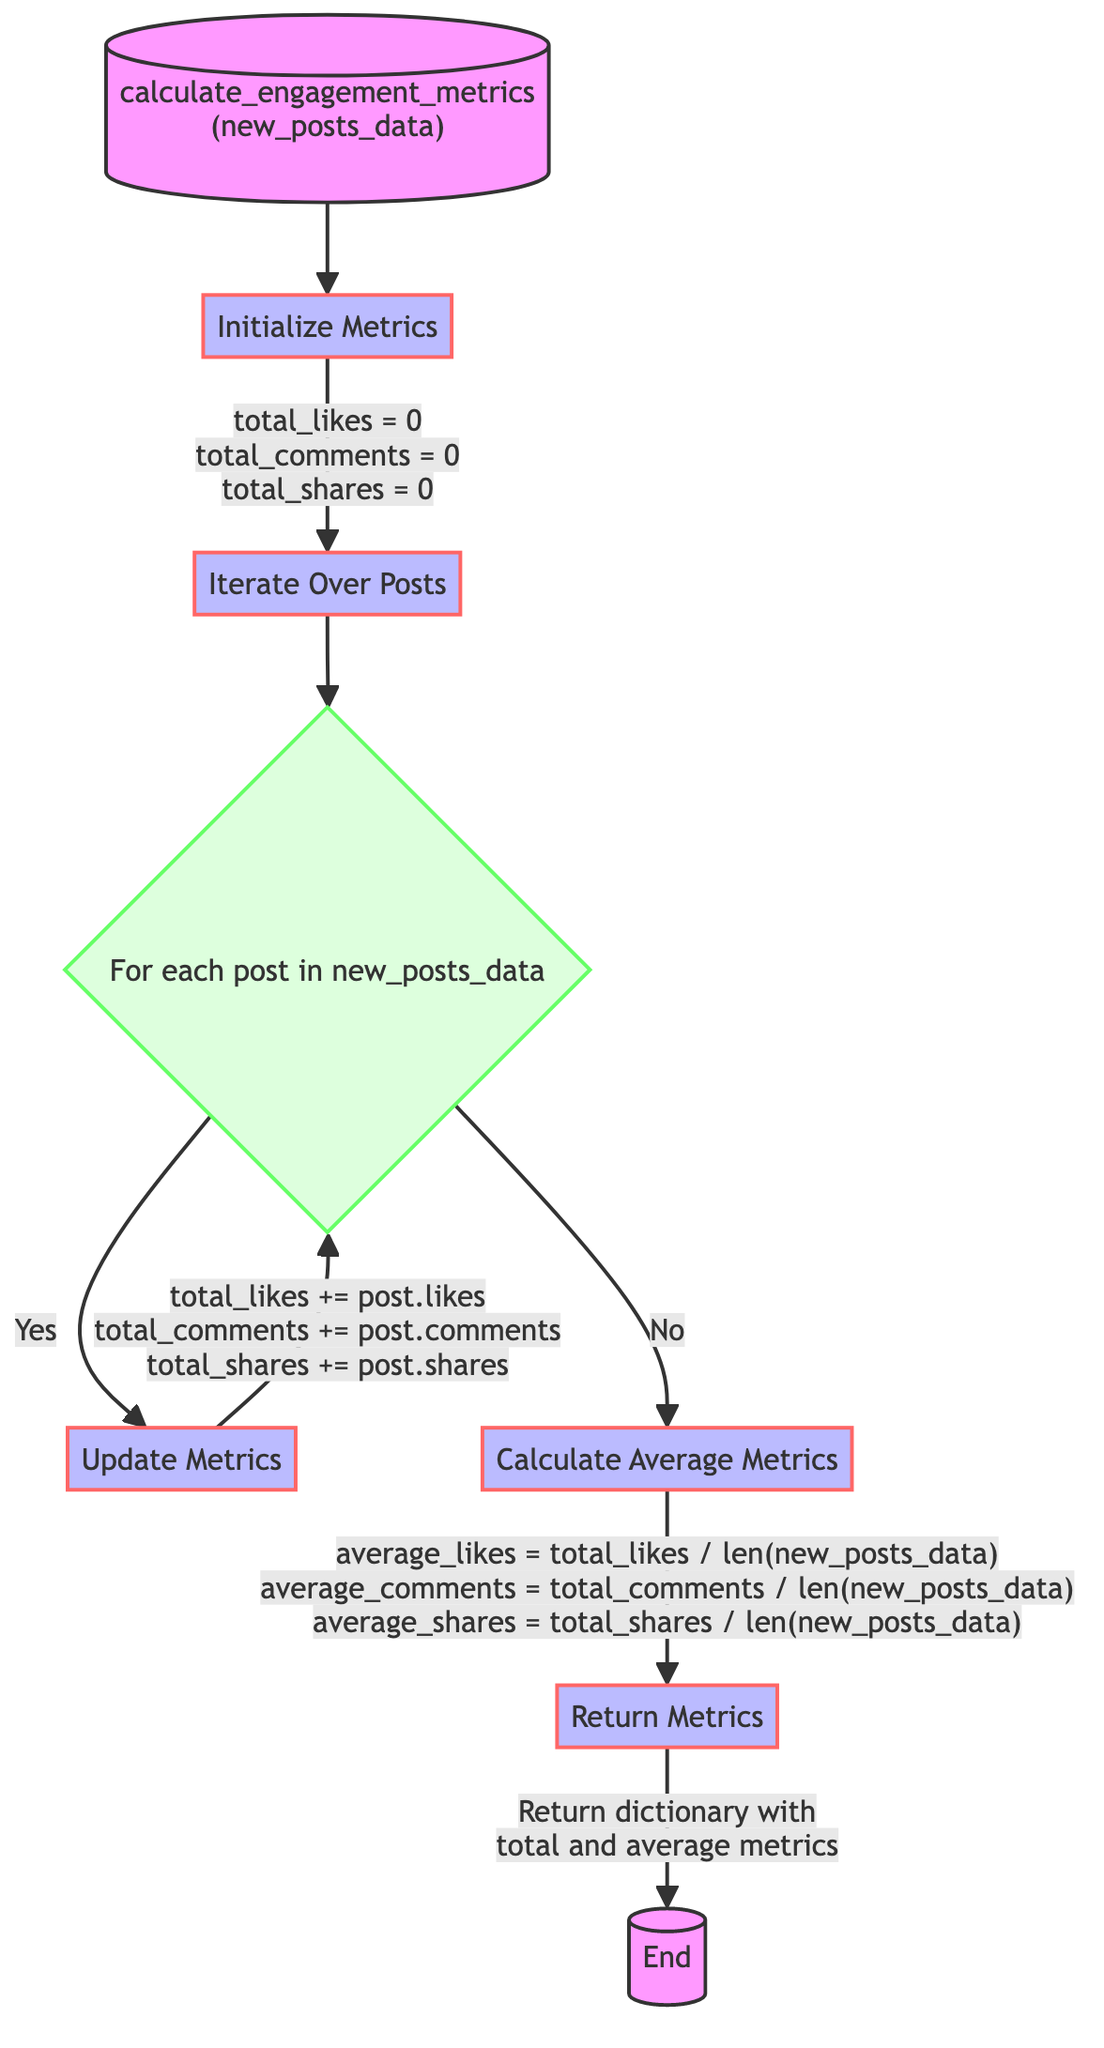What is the name of the function? The diagram clearly shows that the name of the function is "calculate_engagement_metrics".
Answer: calculate_engagement_metrics How many total metrics are initialized? The diagram specifies that three metrics are initialized: likes, comments, and shares.
Answer: three What is the operation performed during the "Update Metrics" step? In the "Update Metrics" step, the operation is to add the likes, comments, and shares from the post to the corresponding total metrics.
Answer: Add post's likes, comments, shares to totals What happens after iterating over posts? After iterating over the posts, the next step is to calculate the average metrics using the totals.
Answer: Calculate Average Metrics What is the output of the function? The output of the function is a dictionary containing total and average metrics.
Answer: Dictionary with total and average metrics What is calculated to find the average likes? The average likes are calculated by dividing the total likes by the number of posts in the new_posts_data.
Answer: total_likes divided by number of posts What variables are set to zero initially? The variables initialized to zero are total_likes, total_comments, and total_shares.
Answer: total_likes, total_comments, total_shares What denotes the completion of the function? The end of the function is denoted by the final node labeled "End".
Answer: End What type of diagram is this? This is a flowchart representing a Python function.
Answer: Flowchart of a Python Function What is the relation between the "Iterate Over Posts" node and the "Calculate Average Metrics" node? The "Iterate Over Posts" node leads to the "Calculate Average Metrics" node only after all posts have been processed, which is indicated by the flow from "No" to "Calculate Average Metrics".
Answer: Iterates until all posts are processed 